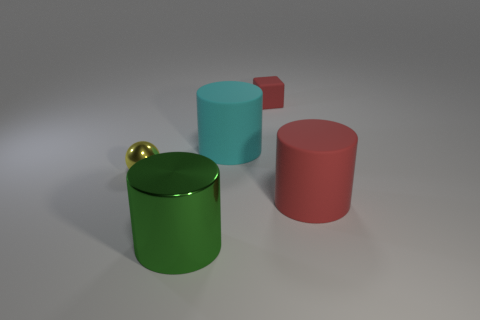What kind of mood or atmosphere do the colors in this image evoke? The colors are soft and muted, contributing to a serene and harmonious mood. The palette includes cool and warm tones, which together offer a welcoming yet somewhat understated atmosphere. 